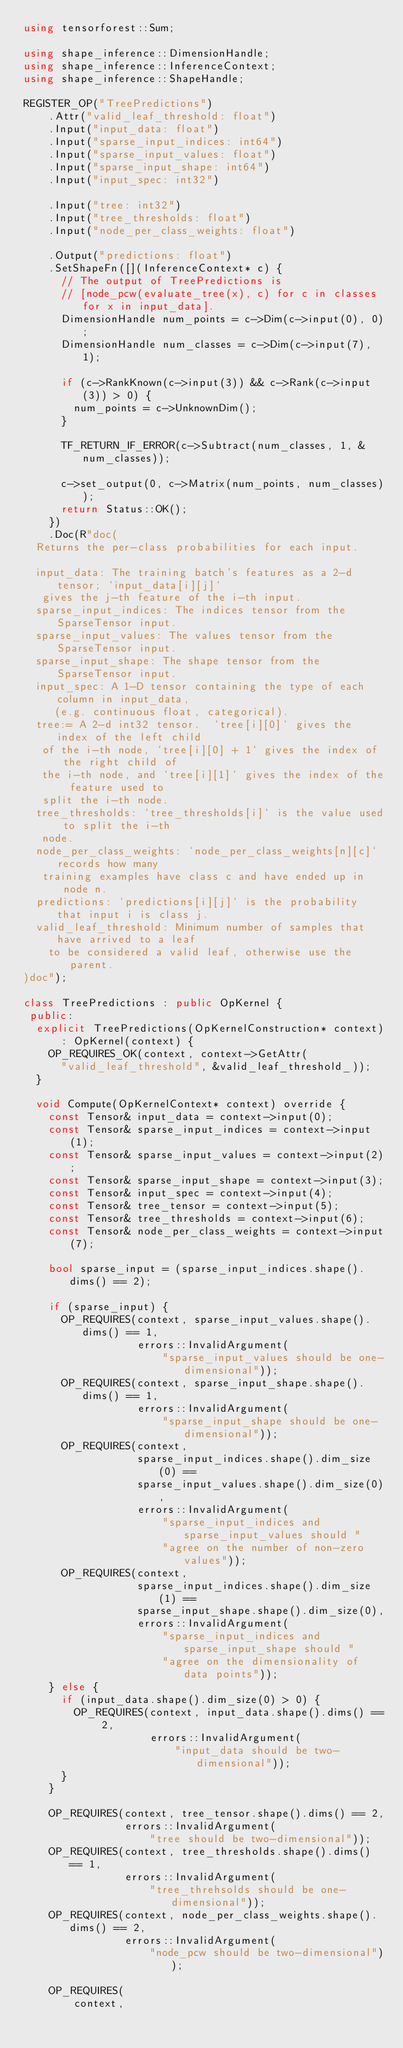<code> <loc_0><loc_0><loc_500><loc_500><_C++_>using tensorforest::Sum;

using shape_inference::DimensionHandle;
using shape_inference::InferenceContext;
using shape_inference::ShapeHandle;

REGISTER_OP("TreePredictions")
    .Attr("valid_leaf_threshold: float")
    .Input("input_data: float")
    .Input("sparse_input_indices: int64")
    .Input("sparse_input_values: float")
    .Input("sparse_input_shape: int64")
    .Input("input_spec: int32")

    .Input("tree: int32")
    .Input("tree_thresholds: float")
    .Input("node_per_class_weights: float")

    .Output("predictions: float")
    .SetShapeFn([](InferenceContext* c) {
      // The output of TreePredictions is
      // [node_pcw(evaluate_tree(x), c) for c in classes for x in input_data].
      DimensionHandle num_points = c->Dim(c->input(0), 0);
      DimensionHandle num_classes = c->Dim(c->input(7), 1);

      if (c->RankKnown(c->input(3)) && c->Rank(c->input(3)) > 0) {
        num_points = c->UnknownDim();
      }

      TF_RETURN_IF_ERROR(c->Subtract(num_classes, 1, &num_classes));

      c->set_output(0, c->Matrix(num_points, num_classes));
      return Status::OK();
    })
    .Doc(R"doc(
  Returns the per-class probabilities for each input.

  input_data: The training batch's features as a 2-d tensor; `input_data[i][j]`
   gives the j-th feature of the i-th input.
  sparse_input_indices: The indices tensor from the SparseTensor input.
  sparse_input_values: The values tensor from the SparseTensor input.
  sparse_input_shape: The shape tensor from the SparseTensor input.
  input_spec: A 1-D tensor containing the type of each column in input_data,
     (e.g. continuous float, categorical).
  tree:= A 2-d int32 tensor.  `tree[i][0]` gives the index of the left child
   of the i-th node, `tree[i][0] + 1` gives the index of the right child of
   the i-th node, and `tree[i][1]` gives the index of the feature used to
   split the i-th node.
  tree_thresholds: `tree_thresholds[i]` is the value used to split the i-th
   node.
  node_per_class_weights: `node_per_class_weights[n][c]` records how many
   training examples have class c and have ended up in node n.
  predictions: `predictions[i][j]` is the probability that input i is class j.
  valid_leaf_threshold: Minimum number of samples that have arrived to a leaf
    to be considered a valid leaf, otherwise use the parent.
)doc");

class TreePredictions : public OpKernel {
 public:
  explicit TreePredictions(OpKernelConstruction* context)
      : OpKernel(context) {
    OP_REQUIRES_OK(context, context->GetAttr(
      "valid_leaf_threshold", &valid_leaf_threshold_));
  }

  void Compute(OpKernelContext* context) override {
    const Tensor& input_data = context->input(0);
    const Tensor& sparse_input_indices = context->input(1);
    const Tensor& sparse_input_values = context->input(2);
    const Tensor& sparse_input_shape = context->input(3);
    const Tensor& input_spec = context->input(4);
    const Tensor& tree_tensor = context->input(5);
    const Tensor& tree_thresholds = context->input(6);
    const Tensor& node_per_class_weights = context->input(7);

    bool sparse_input = (sparse_input_indices.shape().dims() == 2);

    if (sparse_input) {
      OP_REQUIRES(context, sparse_input_values.shape().dims() == 1,
                  errors::InvalidArgument(
                      "sparse_input_values should be one-dimensional"));
      OP_REQUIRES(context, sparse_input_shape.shape().dims() == 1,
                  errors::InvalidArgument(
                      "sparse_input_shape should be one-dimensional"));
      OP_REQUIRES(context,
                  sparse_input_indices.shape().dim_size(0) ==
                  sparse_input_values.shape().dim_size(0),
                  errors::InvalidArgument(
                      "sparse_input_indices and sparse_input_values should "
                      "agree on the number of non-zero values"));
      OP_REQUIRES(context,
                  sparse_input_indices.shape().dim_size(1) ==
                  sparse_input_shape.shape().dim_size(0),
                  errors::InvalidArgument(
                      "sparse_input_indices and sparse_input_shape should "
                      "agree on the dimensionality of data points"));
    } else {
      if (input_data.shape().dim_size(0) > 0) {
        OP_REQUIRES(context, input_data.shape().dims() == 2,
                    errors::InvalidArgument(
                        "input_data should be two-dimensional"));
      }
    }

    OP_REQUIRES(context, tree_tensor.shape().dims() == 2,
                errors::InvalidArgument(
                    "tree should be two-dimensional"));
    OP_REQUIRES(context, tree_thresholds.shape().dims() == 1,
                errors::InvalidArgument(
                    "tree_threhsolds should be one-dimensional"));
    OP_REQUIRES(context, node_per_class_weights.shape().dims() == 2,
                errors::InvalidArgument(
                    "node_pcw should be two-dimensional"));

    OP_REQUIRES(
        context,</code> 